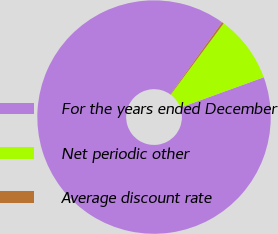<chart> <loc_0><loc_0><loc_500><loc_500><pie_chart><fcel>For the years ended December<fcel>Net periodic other<fcel>Average discount rate<nl><fcel>90.44%<fcel>9.29%<fcel>0.27%<nl></chart> 